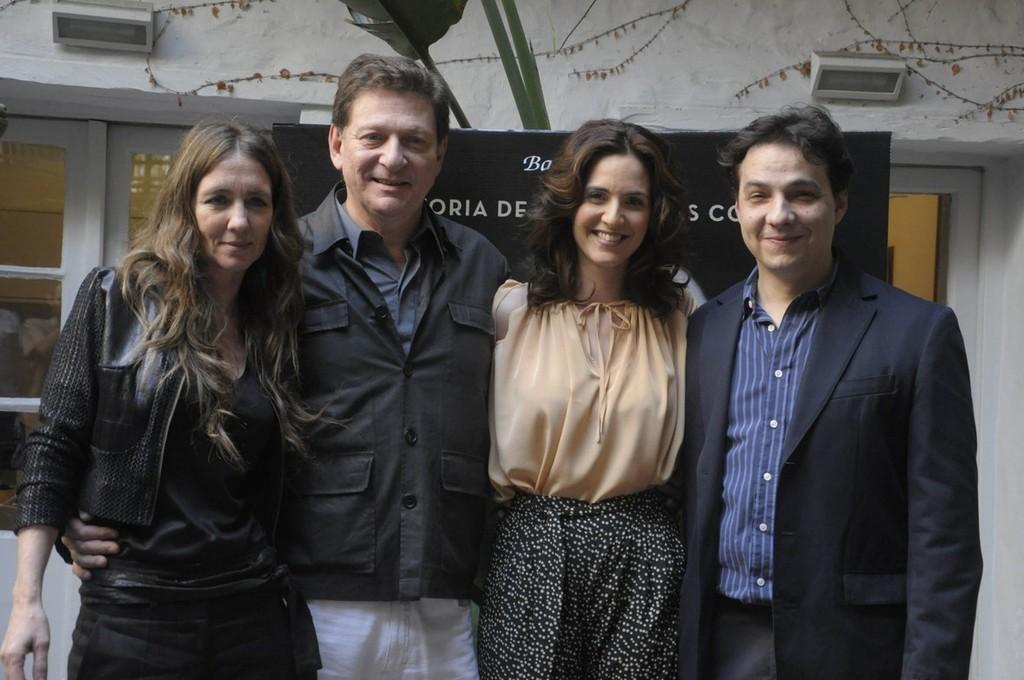Can you describe this image briefly? In this image, we can see people wearing clothes and standing in front of the board. There is a window on the left side of the image. There is a light in the top left and in the top right of the image. 